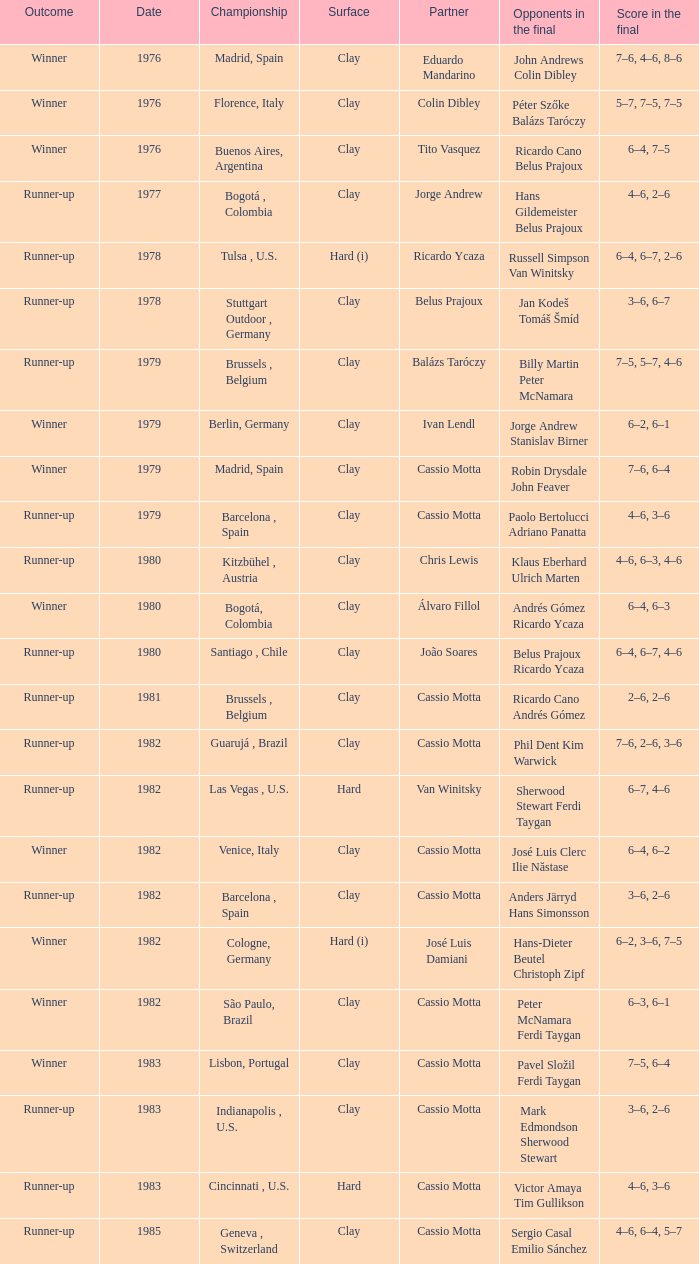What is the outcome on a hard surface, when the score in the final was 4–6, 3–6? Runner-up. 